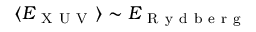Convert formula to latex. <formula><loc_0><loc_0><loc_500><loc_500>\langle E _ { X U V } \rangle \sim E _ { R y d b e r g }</formula> 